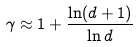<formula> <loc_0><loc_0><loc_500><loc_500>\gamma \approx 1 + \frac { \ln ( d + 1 ) } { \ln d }</formula> 